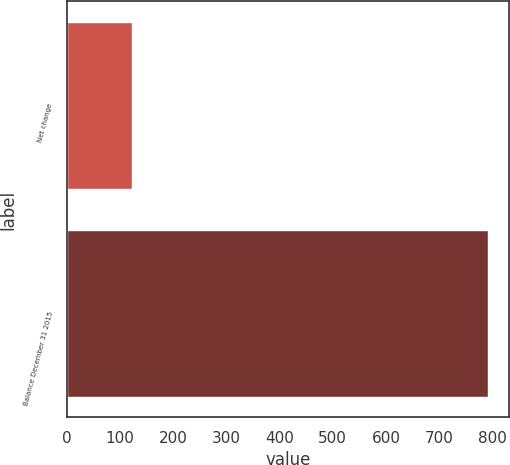Convert chart. <chart><loc_0><loc_0><loc_500><loc_500><bar_chart><fcel>Net change<fcel>Balance December 31 2015<nl><fcel>123<fcel>792<nl></chart> 